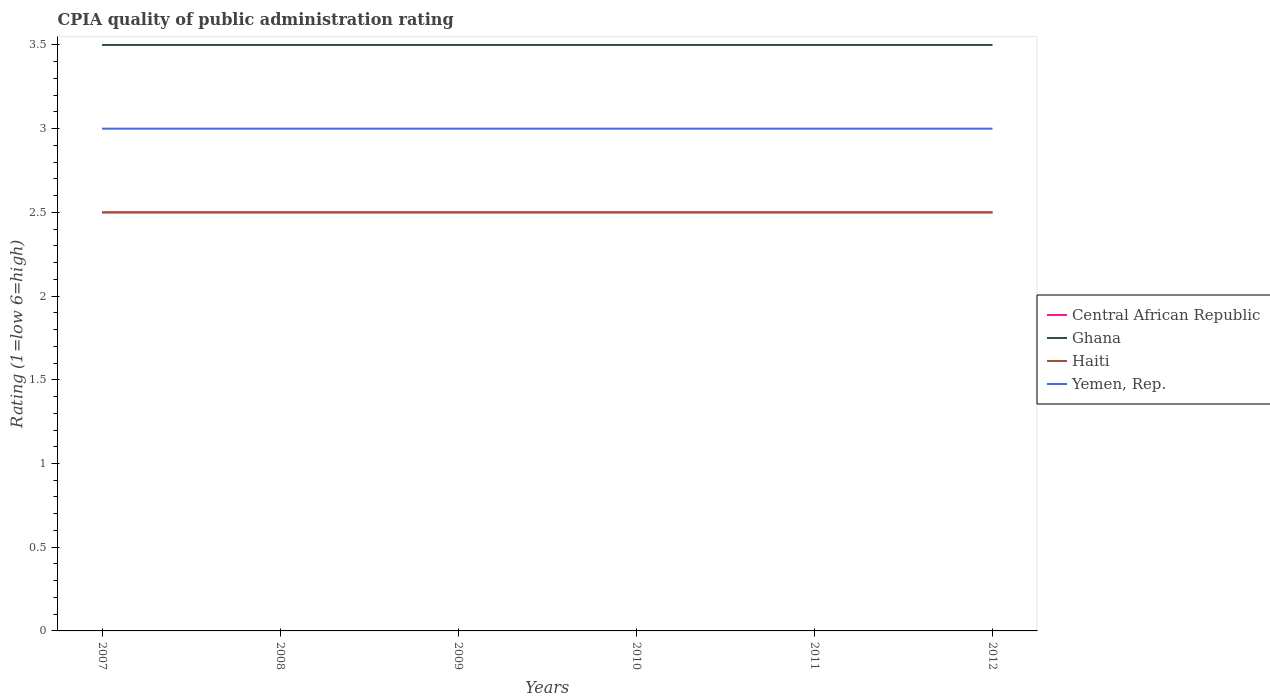How many different coloured lines are there?
Make the answer very short. 4. Does the line corresponding to Ghana intersect with the line corresponding to Yemen, Rep.?
Your answer should be compact. No. Across all years, what is the maximum CPIA rating in Yemen, Rep.?
Your answer should be very brief. 3. In which year was the CPIA rating in Central African Republic maximum?
Offer a very short reply. 2007. What is the total CPIA rating in Haiti in the graph?
Your answer should be compact. 0. What is the difference between the highest and the lowest CPIA rating in Ghana?
Make the answer very short. 0. Is the CPIA rating in Central African Republic strictly greater than the CPIA rating in Yemen, Rep. over the years?
Offer a terse response. Yes. Does the graph contain grids?
Your response must be concise. No. What is the title of the graph?
Your answer should be very brief. CPIA quality of public administration rating. Does "Thailand" appear as one of the legend labels in the graph?
Your answer should be very brief. No. What is the label or title of the X-axis?
Your answer should be compact. Years. What is the Rating (1=low 6=high) of Central African Republic in 2007?
Your response must be concise. 2.5. What is the Rating (1=low 6=high) in Ghana in 2007?
Ensure brevity in your answer.  3.5. What is the Rating (1=low 6=high) of Central African Republic in 2008?
Your answer should be compact. 2.5. What is the Rating (1=low 6=high) of Haiti in 2008?
Ensure brevity in your answer.  2.5. What is the Rating (1=low 6=high) of Yemen, Rep. in 2008?
Make the answer very short. 3. What is the Rating (1=low 6=high) in Ghana in 2009?
Give a very brief answer. 3.5. What is the Rating (1=low 6=high) of Haiti in 2009?
Your response must be concise. 2.5. What is the Rating (1=low 6=high) in Central African Republic in 2010?
Give a very brief answer. 2.5. What is the Rating (1=low 6=high) in Ghana in 2010?
Provide a succinct answer. 3.5. What is the Rating (1=low 6=high) in Ghana in 2011?
Give a very brief answer. 3.5. What is the Rating (1=low 6=high) in Haiti in 2011?
Offer a very short reply. 2.5. What is the Rating (1=low 6=high) of Central African Republic in 2012?
Ensure brevity in your answer.  2.5. What is the Rating (1=low 6=high) of Ghana in 2012?
Your answer should be compact. 3.5. What is the Rating (1=low 6=high) in Haiti in 2012?
Offer a terse response. 2.5. Across all years, what is the maximum Rating (1=low 6=high) in Central African Republic?
Provide a short and direct response. 2.5. Across all years, what is the maximum Rating (1=low 6=high) in Ghana?
Provide a short and direct response. 3.5. Across all years, what is the maximum Rating (1=low 6=high) of Haiti?
Your response must be concise. 2.5. Across all years, what is the maximum Rating (1=low 6=high) of Yemen, Rep.?
Give a very brief answer. 3. Across all years, what is the minimum Rating (1=low 6=high) in Ghana?
Your answer should be compact. 3.5. Across all years, what is the minimum Rating (1=low 6=high) in Haiti?
Your answer should be very brief. 2.5. What is the total Rating (1=low 6=high) in Central African Republic in the graph?
Provide a succinct answer. 15. What is the total Rating (1=low 6=high) in Ghana in the graph?
Make the answer very short. 21. What is the total Rating (1=low 6=high) of Haiti in the graph?
Your answer should be very brief. 15. What is the difference between the Rating (1=low 6=high) in Central African Republic in 2007 and that in 2010?
Make the answer very short. 0. What is the difference between the Rating (1=low 6=high) in Haiti in 2007 and that in 2010?
Provide a short and direct response. 0. What is the difference between the Rating (1=low 6=high) in Central African Republic in 2007 and that in 2011?
Keep it short and to the point. 0. What is the difference between the Rating (1=low 6=high) in Haiti in 2007 and that in 2012?
Your response must be concise. 0. What is the difference between the Rating (1=low 6=high) in Central African Republic in 2008 and that in 2009?
Provide a short and direct response. 0. What is the difference between the Rating (1=low 6=high) in Haiti in 2008 and that in 2009?
Your answer should be compact. 0. What is the difference between the Rating (1=low 6=high) in Central African Republic in 2008 and that in 2010?
Keep it short and to the point. 0. What is the difference between the Rating (1=low 6=high) in Haiti in 2008 and that in 2010?
Your answer should be very brief. 0. What is the difference between the Rating (1=low 6=high) in Yemen, Rep. in 2008 and that in 2010?
Give a very brief answer. 0. What is the difference between the Rating (1=low 6=high) in Central African Republic in 2008 and that in 2011?
Make the answer very short. 0. What is the difference between the Rating (1=low 6=high) of Haiti in 2008 and that in 2011?
Offer a very short reply. 0. What is the difference between the Rating (1=low 6=high) of Yemen, Rep. in 2008 and that in 2011?
Ensure brevity in your answer.  0. What is the difference between the Rating (1=low 6=high) of Ghana in 2008 and that in 2012?
Make the answer very short. 0. What is the difference between the Rating (1=low 6=high) of Haiti in 2008 and that in 2012?
Provide a succinct answer. 0. What is the difference between the Rating (1=low 6=high) in Ghana in 2009 and that in 2010?
Provide a succinct answer. 0. What is the difference between the Rating (1=low 6=high) of Haiti in 2009 and that in 2010?
Offer a very short reply. 0. What is the difference between the Rating (1=low 6=high) of Central African Republic in 2009 and that in 2011?
Your answer should be compact. 0. What is the difference between the Rating (1=low 6=high) of Ghana in 2009 and that in 2011?
Offer a terse response. 0. What is the difference between the Rating (1=low 6=high) in Yemen, Rep. in 2009 and that in 2011?
Ensure brevity in your answer.  0. What is the difference between the Rating (1=low 6=high) in Central African Republic in 2009 and that in 2012?
Keep it short and to the point. 0. What is the difference between the Rating (1=low 6=high) of Ghana in 2010 and that in 2011?
Your answer should be compact. 0. What is the difference between the Rating (1=low 6=high) of Haiti in 2010 and that in 2011?
Your answer should be compact. 0. What is the difference between the Rating (1=low 6=high) of Yemen, Rep. in 2010 and that in 2011?
Offer a very short reply. 0. What is the difference between the Rating (1=low 6=high) of Central African Republic in 2010 and that in 2012?
Offer a very short reply. 0. What is the difference between the Rating (1=low 6=high) of Haiti in 2010 and that in 2012?
Provide a succinct answer. 0. What is the difference between the Rating (1=low 6=high) in Ghana in 2011 and that in 2012?
Give a very brief answer. 0. What is the difference between the Rating (1=low 6=high) in Haiti in 2011 and that in 2012?
Provide a short and direct response. 0. What is the difference between the Rating (1=low 6=high) of Yemen, Rep. in 2011 and that in 2012?
Your answer should be very brief. 0. What is the difference between the Rating (1=low 6=high) of Ghana in 2007 and the Rating (1=low 6=high) of Haiti in 2008?
Give a very brief answer. 1. What is the difference between the Rating (1=low 6=high) in Haiti in 2007 and the Rating (1=low 6=high) in Yemen, Rep. in 2008?
Provide a short and direct response. -0.5. What is the difference between the Rating (1=low 6=high) of Central African Republic in 2007 and the Rating (1=low 6=high) of Ghana in 2009?
Offer a terse response. -1. What is the difference between the Rating (1=low 6=high) of Central African Republic in 2007 and the Rating (1=low 6=high) of Yemen, Rep. in 2009?
Provide a succinct answer. -0.5. What is the difference between the Rating (1=low 6=high) in Haiti in 2007 and the Rating (1=low 6=high) in Yemen, Rep. in 2009?
Keep it short and to the point. -0.5. What is the difference between the Rating (1=low 6=high) of Central African Republic in 2007 and the Rating (1=low 6=high) of Yemen, Rep. in 2010?
Ensure brevity in your answer.  -0.5. What is the difference between the Rating (1=low 6=high) of Ghana in 2007 and the Rating (1=low 6=high) of Haiti in 2010?
Your answer should be very brief. 1. What is the difference between the Rating (1=low 6=high) of Ghana in 2007 and the Rating (1=low 6=high) of Yemen, Rep. in 2010?
Your answer should be very brief. 0.5. What is the difference between the Rating (1=low 6=high) of Haiti in 2007 and the Rating (1=low 6=high) of Yemen, Rep. in 2010?
Your answer should be very brief. -0.5. What is the difference between the Rating (1=low 6=high) of Central African Republic in 2007 and the Rating (1=low 6=high) of Ghana in 2011?
Provide a short and direct response. -1. What is the difference between the Rating (1=low 6=high) of Central African Republic in 2007 and the Rating (1=low 6=high) of Haiti in 2011?
Give a very brief answer. 0. What is the difference between the Rating (1=low 6=high) of Ghana in 2007 and the Rating (1=low 6=high) of Haiti in 2011?
Keep it short and to the point. 1. What is the difference between the Rating (1=low 6=high) in Ghana in 2007 and the Rating (1=low 6=high) in Yemen, Rep. in 2011?
Offer a terse response. 0.5. What is the difference between the Rating (1=low 6=high) of Haiti in 2007 and the Rating (1=low 6=high) of Yemen, Rep. in 2011?
Offer a very short reply. -0.5. What is the difference between the Rating (1=low 6=high) of Central African Republic in 2007 and the Rating (1=low 6=high) of Ghana in 2012?
Ensure brevity in your answer.  -1. What is the difference between the Rating (1=low 6=high) in Central African Republic in 2007 and the Rating (1=low 6=high) in Haiti in 2012?
Your answer should be very brief. 0. What is the difference between the Rating (1=low 6=high) in Central African Republic in 2008 and the Rating (1=low 6=high) in Haiti in 2009?
Give a very brief answer. 0. What is the difference between the Rating (1=low 6=high) in Central African Republic in 2008 and the Rating (1=low 6=high) in Ghana in 2010?
Offer a very short reply. -1. What is the difference between the Rating (1=low 6=high) of Central African Republic in 2008 and the Rating (1=low 6=high) of Yemen, Rep. in 2010?
Give a very brief answer. -0.5. What is the difference between the Rating (1=low 6=high) in Ghana in 2008 and the Rating (1=low 6=high) in Haiti in 2010?
Provide a short and direct response. 1. What is the difference between the Rating (1=low 6=high) in Ghana in 2008 and the Rating (1=low 6=high) in Yemen, Rep. in 2010?
Offer a very short reply. 0.5. What is the difference between the Rating (1=low 6=high) of Haiti in 2008 and the Rating (1=low 6=high) of Yemen, Rep. in 2010?
Your response must be concise. -0.5. What is the difference between the Rating (1=low 6=high) in Central African Republic in 2008 and the Rating (1=low 6=high) in Ghana in 2011?
Give a very brief answer. -1. What is the difference between the Rating (1=low 6=high) of Central African Republic in 2008 and the Rating (1=low 6=high) of Haiti in 2011?
Your answer should be compact. 0. What is the difference between the Rating (1=low 6=high) in Ghana in 2008 and the Rating (1=low 6=high) in Yemen, Rep. in 2011?
Provide a succinct answer. 0.5. What is the difference between the Rating (1=low 6=high) in Haiti in 2008 and the Rating (1=low 6=high) in Yemen, Rep. in 2011?
Your answer should be very brief. -0.5. What is the difference between the Rating (1=low 6=high) in Central African Republic in 2008 and the Rating (1=low 6=high) in Ghana in 2012?
Offer a terse response. -1. What is the difference between the Rating (1=low 6=high) in Ghana in 2008 and the Rating (1=low 6=high) in Haiti in 2012?
Provide a succinct answer. 1. What is the difference between the Rating (1=low 6=high) in Central African Republic in 2009 and the Rating (1=low 6=high) in Ghana in 2010?
Offer a very short reply. -1. What is the difference between the Rating (1=low 6=high) in Central African Republic in 2009 and the Rating (1=low 6=high) in Haiti in 2010?
Your answer should be very brief. 0. What is the difference between the Rating (1=low 6=high) of Ghana in 2009 and the Rating (1=low 6=high) of Haiti in 2010?
Offer a very short reply. 1. What is the difference between the Rating (1=low 6=high) of Ghana in 2009 and the Rating (1=low 6=high) of Yemen, Rep. in 2010?
Make the answer very short. 0.5. What is the difference between the Rating (1=low 6=high) in Central African Republic in 2009 and the Rating (1=low 6=high) in Ghana in 2011?
Your response must be concise. -1. What is the difference between the Rating (1=low 6=high) in Central African Republic in 2009 and the Rating (1=low 6=high) in Haiti in 2011?
Offer a very short reply. 0. What is the difference between the Rating (1=low 6=high) of Central African Republic in 2009 and the Rating (1=low 6=high) of Yemen, Rep. in 2011?
Keep it short and to the point. -0.5. What is the difference between the Rating (1=low 6=high) in Ghana in 2009 and the Rating (1=low 6=high) in Haiti in 2011?
Provide a succinct answer. 1. What is the difference between the Rating (1=low 6=high) in Ghana in 2009 and the Rating (1=low 6=high) in Yemen, Rep. in 2011?
Your answer should be compact. 0.5. What is the difference between the Rating (1=low 6=high) in Central African Republic in 2009 and the Rating (1=low 6=high) in Haiti in 2012?
Offer a very short reply. 0. What is the difference between the Rating (1=low 6=high) of Central African Republic in 2009 and the Rating (1=low 6=high) of Yemen, Rep. in 2012?
Provide a succinct answer. -0.5. What is the difference between the Rating (1=low 6=high) of Ghana in 2009 and the Rating (1=low 6=high) of Haiti in 2012?
Your answer should be compact. 1. What is the difference between the Rating (1=low 6=high) in Ghana in 2009 and the Rating (1=low 6=high) in Yemen, Rep. in 2012?
Your answer should be compact. 0.5. What is the difference between the Rating (1=low 6=high) in Haiti in 2009 and the Rating (1=low 6=high) in Yemen, Rep. in 2012?
Provide a short and direct response. -0.5. What is the difference between the Rating (1=low 6=high) of Central African Republic in 2010 and the Rating (1=low 6=high) of Ghana in 2011?
Ensure brevity in your answer.  -1. What is the difference between the Rating (1=low 6=high) in Central African Republic in 2010 and the Rating (1=low 6=high) in Haiti in 2011?
Make the answer very short. 0. What is the difference between the Rating (1=low 6=high) of Central African Republic in 2010 and the Rating (1=low 6=high) of Yemen, Rep. in 2011?
Give a very brief answer. -0.5. What is the difference between the Rating (1=low 6=high) of Ghana in 2010 and the Rating (1=low 6=high) of Haiti in 2011?
Keep it short and to the point. 1. What is the difference between the Rating (1=low 6=high) of Central African Republic in 2010 and the Rating (1=low 6=high) of Ghana in 2012?
Your answer should be compact. -1. What is the difference between the Rating (1=low 6=high) in Central African Republic in 2011 and the Rating (1=low 6=high) in Ghana in 2012?
Give a very brief answer. -1. What is the difference between the Rating (1=low 6=high) in Central African Republic in 2011 and the Rating (1=low 6=high) in Haiti in 2012?
Your answer should be compact. 0. What is the difference between the Rating (1=low 6=high) in Central African Republic in 2011 and the Rating (1=low 6=high) in Yemen, Rep. in 2012?
Offer a terse response. -0.5. What is the difference between the Rating (1=low 6=high) in Ghana in 2011 and the Rating (1=low 6=high) in Yemen, Rep. in 2012?
Keep it short and to the point. 0.5. What is the difference between the Rating (1=low 6=high) in Haiti in 2011 and the Rating (1=low 6=high) in Yemen, Rep. in 2012?
Offer a terse response. -0.5. What is the average Rating (1=low 6=high) of Ghana per year?
Your answer should be compact. 3.5. What is the average Rating (1=low 6=high) in Yemen, Rep. per year?
Ensure brevity in your answer.  3. In the year 2007, what is the difference between the Rating (1=low 6=high) in Central African Republic and Rating (1=low 6=high) in Haiti?
Keep it short and to the point. 0. In the year 2007, what is the difference between the Rating (1=low 6=high) of Central African Republic and Rating (1=low 6=high) of Yemen, Rep.?
Offer a very short reply. -0.5. In the year 2007, what is the difference between the Rating (1=low 6=high) of Ghana and Rating (1=low 6=high) of Yemen, Rep.?
Your response must be concise. 0.5. In the year 2007, what is the difference between the Rating (1=low 6=high) in Haiti and Rating (1=low 6=high) in Yemen, Rep.?
Your answer should be very brief. -0.5. In the year 2008, what is the difference between the Rating (1=low 6=high) in Central African Republic and Rating (1=low 6=high) in Haiti?
Provide a succinct answer. 0. In the year 2008, what is the difference between the Rating (1=low 6=high) in Central African Republic and Rating (1=low 6=high) in Yemen, Rep.?
Your response must be concise. -0.5. In the year 2008, what is the difference between the Rating (1=low 6=high) in Ghana and Rating (1=low 6=high) in Yemen, Rep.?
Your response must be concise. 0.5. In the year 2009, what is the difference between the Rating (1=low 6=high) of Central African Republic and Rating (1=low 6=high) of Ghana?
Your answer should be very brief. -1. In the year 2009, what is the difference between the Rating (1=low 6=high) in Central African Republic and Rating (1=low 6=high) in Haiti?
Make the answer very short. 0. In the year 2009, what is the difference between the Rating (1=low 6=high) of Haiti and Rating (1=low 6=high) of Yemen, Rep.?
Provide a short and direct response. -0.5. In the year 2010, what is the difference between the Rating (1=low 6=high) in Central African Republic and Rating (1=low 6=high) in Ghana?
Provide a succinct answer. -1. In the year 2010, what is the difference between the Rating (1=low 6=high) in Central African Republic and Rating (1=low 6=high) in Haiti?
Offer a very short reply. 0. In the year 2010, what is the difference between the Rating (1=low 6=high) of Central African Republic and Rating (1=low 6=high) of Yemen, Rep.?
Provide a succinct answer. -0.5. In the year 2010, what is the difference between the Rating (1=low 6=high) of Ghana and Rating (1=low 6=high) of Haiti?
Provide a short and direct response. 1. In the year 2011, what is the difference between the Rating (1=low 6=high) in Central African Republic and Rating (1=low 6=high) in Haiti?
Offer a terse response. 0. In the year 2011, what is the difference between the Rating (1=low 6=high) in Ghana and Rating (1=low 6=high) in Haiti?
Your answer should be very brief. 1. In the year 2011, what is the difference between the Rating (1=low 6=high) in Haiti and Rating (1=low 6=high) in Yemen, Rep.?
Make the answer very short. -0.5. In the year 2012, what is the difference between the Rating (1=low 6=high) of Central African Republic and Rating (1=low 6=high) of Ghana?
Offer a very short reply. -1. In the year 2012, what is the difference between the Rating (1=low 6=high) of Central African Republic and Rating (1=low 6=high) of Yemen, Rep.?
Offer a very short reply. -0.5. In the year 2012, what is the difference between the Rating (1=low 6=high) in Ghana and Rating (1=low 6=high) in Haiti?
Provide a succinct answer. 1. In the year 2012, what is the difference between the Rating (1=low 6=high) of Haiti and Rating (1=low 6=high) of Yemen, Rep.?
Your answer should be compact. -0.5. What is the ratio of the Rating (1=low 6=high) of Haiti in 2007 to that in 2008?
Your response must be concise. 1. What is the ratio of the Rating (1=low 6=high) of Central African Republic in 2007 to that in 2009?
Provide a succinct answer. 1. What is the ratio of the Rating (1=low 6=high) of Yemen, Rep. in 2007 to that in 2009?
Your answer should be compact. 1. What is the ratio of the Rating (1=low 6=high) of Haiti in 2007 to that in 2010?
Your answer should be very brief. 1. What is the ratio of the Rating (1=low 6=high) in Yemen, Rep. in 2007 to that in 2010?
Make the answer very short. 1. What is the ratio of the Rating (1=low 6=high) of Central African Republic in 2007 to that in 2011?
Your answer should be very brief. 1. What is the ratio of the Rating (1=low 6=high) in Ghana in 2007 to that in 2011?
Offer a terse response. 1. What is the ratio of the Rating (1=low 6=high) of Yemen, Rep. in 2007 to that in 2012?
Your answer should be very brief. 1. What is the ratio of the Rating (1=low 6=high) of Central African Republic in 2008 to that in 2009?
Your answer should be very brief. 1. What is the ratio of the Rating (1=low 6=high) in Haiti in 2008 to that in 2010?
Your answer should be very brief. 1. What is the ratio of the Rating (1=low 6=high) of Haiti in 2008 to that in 2011?
Offer a very short reply. 1. What is the ratio of the Rating (1=low 6=high) in Yemen, Rep. in 2008 to that in 2011?
Your response must be concise. 1. What is the ratio of the Rating (1=low 6=high) of Central African Republic in 2008 to that in 2012?
Offer a very short reply. 1. What is the ratio of the Rating (1=low 6=high) of Haiti in 2008 to that in 2012?
Offer a very short reply. 1. What is the ratio of the Rating (1=low 6=high) of Yemen, Rep. in 2008 to that in 2012?
Give a very brief answer. 1. What is the ratio of the Rating (1=low 6=high) of Central African Republic in 2009 to that in 2010?
Your answer should be compact. 1. What is the ratio of the Rating (1=low 6=high) in Yemen, Rep. in 2009 to that in 2010?
Give a very brief answer. 1. What is the ratio of the Rating (1=low 6=high) in Ghana in 2009 to that in 2011?
Ensure brevity in your answer.  1. What is the ratio of the Rating (1=low 6=high) in Yemen, Rep. in 2009 to that in 2011?
Ensure brevity in your answer.  1. What is the ratio of the Rating (1=low 6=high) in Haiti in 2009 to that in 2012?
Ensure brevity in your answer.  1. What is the ratio of the Rating (1=low 6=high) in Yemen, Rep. in 2009 to that in 2012?
Offer a very short reply. 1. What is the ratio of the Rating (1=low 6=high) in Central African Republic in 2010 to that in 2011?
Keep it short and to the point. 1. What is the ratio of the Rating (1=low 6=high) in Ghana in 2010 to that in 2011?
Offer a very short reply. 1. What is the ratio of the Rating (1=low 6=high) in Yemen, Rep. in 2010 to that in 2011?
Your response must be concise. 1. What is the ratio of the Rating (1=low 6=high) in Haiti in 2010 to that in 2012?
Offer a very short reply. 1. What is the ratio of the Rating (1=low 6=high) in Yemen, Rep. in 2010 to that in 2012?
Provide a short and direct response. 1. What is the ratio of the Rating (1=low 6=high) in Haiti in 2011 to that in 2012?
Give a very brief answer. 1. What is the ratio of the Rating (1=low 6=high) in Yemen, Rep. in 2011 to that in 2012?
Your response must be concise. 1. What is the difference between the highest and the second highest Rating (1=low 6=high) in Central African Republic?
Offer a very short reply. 0. What is the difference between the highest and the second highest Rating (1=low 6=high) in Ghana?
Your answer should be compact. 0. What is the difference between the highest and the second highest Rating (1=low 6=high) in Haiti?
Provide a short and direct response. 0. What is the difference between the highest and the lowest Rating (1=low 6=high) of Central African Republic?
Ensure brevity in your answer.  0. What is the difference between the highest and the lowest Rating (1=low 6=high) in Ghana?
Make the answer very short. 0. What is the difference between the highest and the lowest Rating (1=low 6=high) of Yemen, Rep.?
Offer a very short reply. 0. 